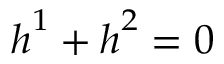<formula> <loc_0><loc_0><loc_500><loc_500>h ^ { 1 } + h ^ { 2 } = 0</formula> 